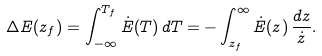<formula> <loc_0><loc_0><loc_500><loc_500>\Delta E ( z _ { f } ) = \int _ { - \infty } ^ { T _ { f } } \dot { E } ( T ) \, d T = - \int _ { z _ { f } } ^ { \infty } \dot { E } ( z ) \, \frac { d z } { \dot { z } } .</formula> 